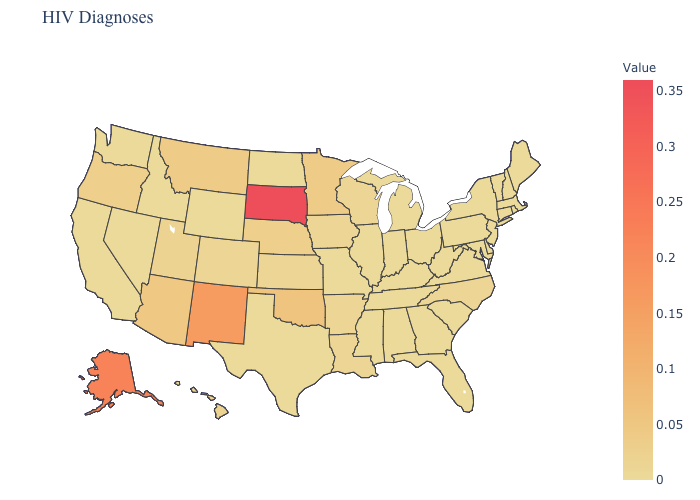Does Oregon have the lowest value in the West?
Keep it brief. No. Among the states that border Wyoming , does Nebraska have the highest value?
Concise answer only. No. Which states hav the highest value in the West?
Short answer required. Alaska. Does Georgia have a higher value than New Mexico?
Quick response, please. No. Is the legend a continuous bar?
Concise answer only. Yes. 